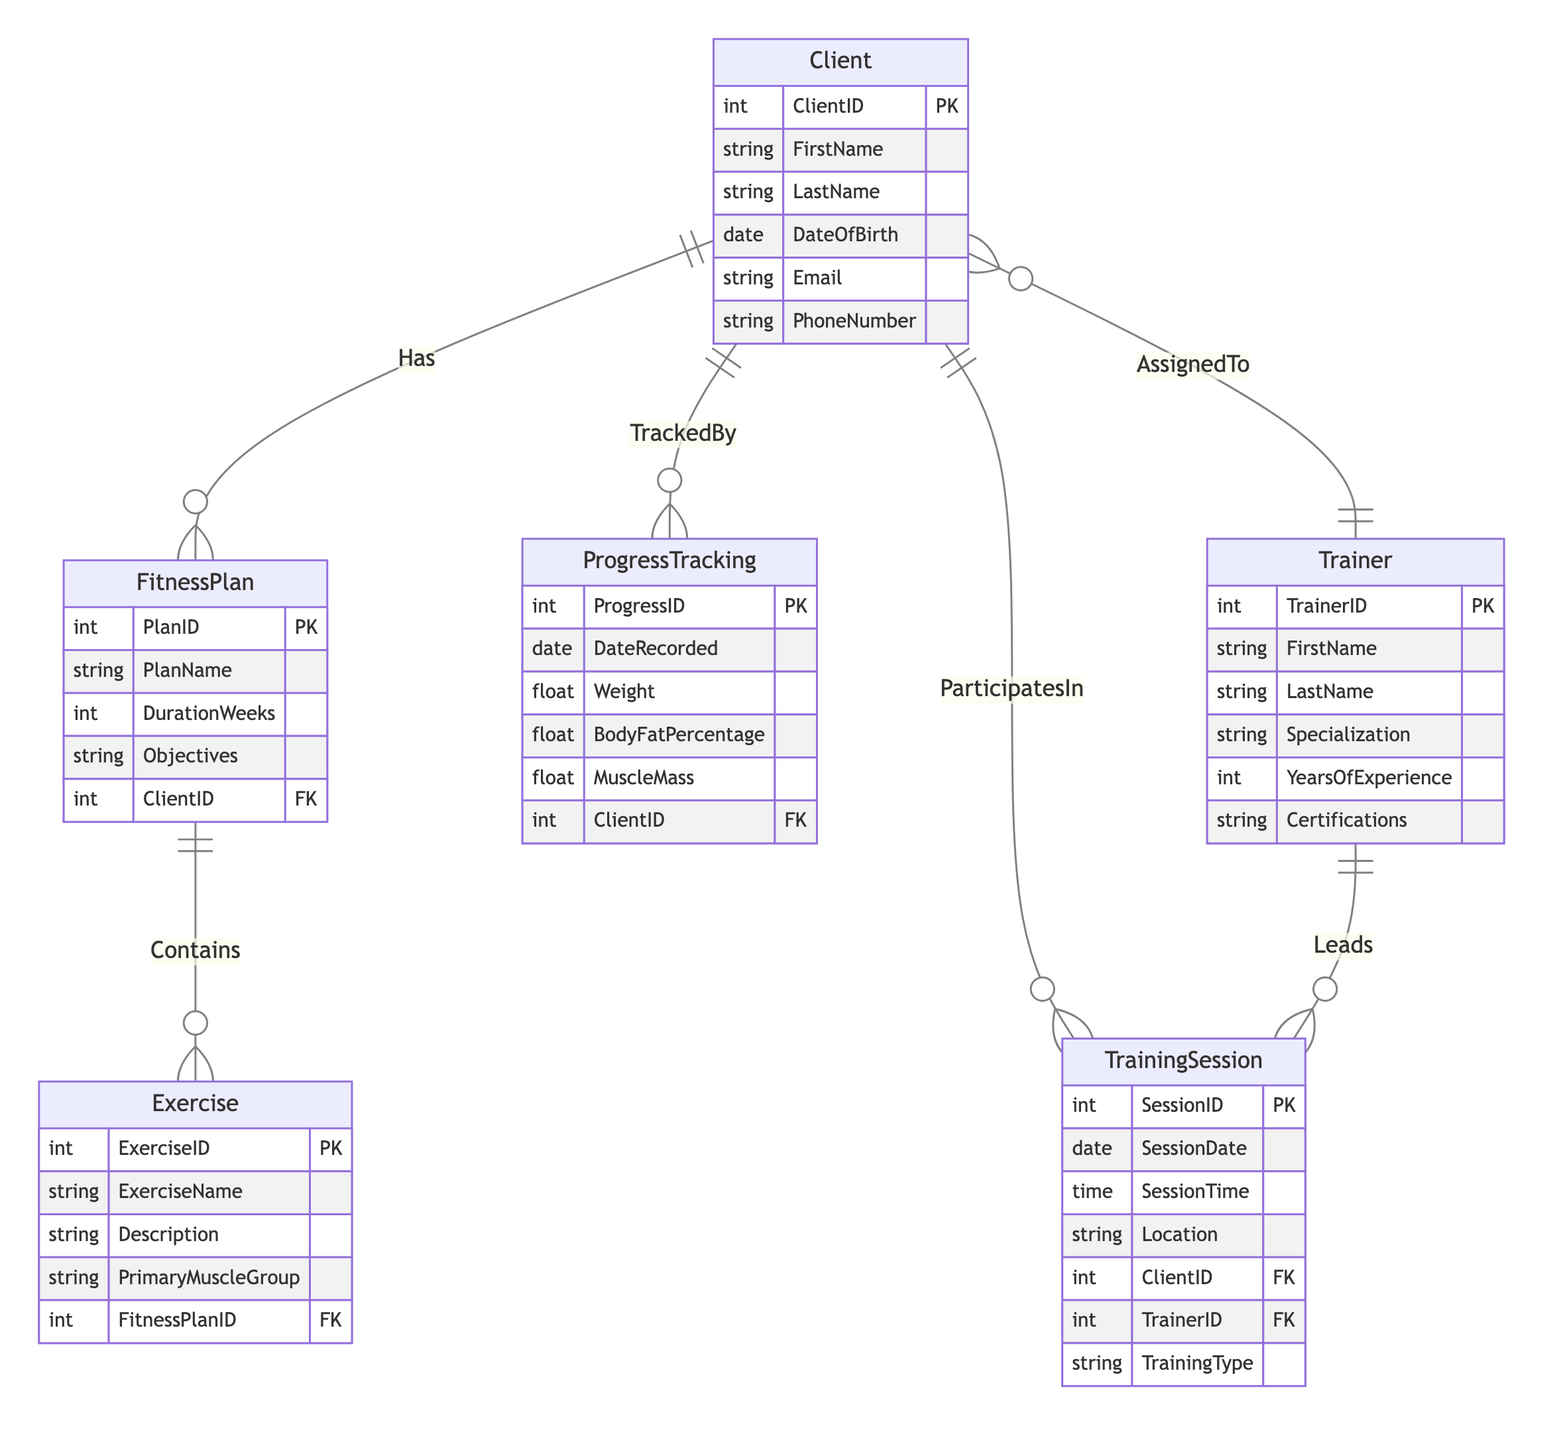What is the primary key of the Client entity? The primary key of the Client entity is defined as ClientID. It is specified under the attributes of the Client entity in the diagram.
Answer: ClientID How many attributes does the Trainer entity have? The Trainer entity has six attributes listed: TrainerID, FirstName, LastName, Specialization, YearsOfExperience, and Certifications. Counting these gives us a total of six attributes.
Answer: 6 What relationship exists between Client and Trainer? The relationship defined between Client and Trainer is "AssignedTo", indicating that each Client is assigned to one Trainer, which reflects a Many-to-One relationship.
Answer: AssignedTo How many different entities are there in the diagram? The diagram lists six entities, which are Client, Trainer, TrainingSession, FitnessPlan, Exercise, and ProgressTracking. Counting these gives us six distinct entities.
Answer: 6 What does a FitnessPlan contain? A FitnessPlan contains Exercises, which is defined by the relationship "Contains". This means that there can be multiple Exercises associated with a single FitnessPlan.
Answer: Exercises Which entity tracks the progress of clients? The ProgressTracking entity is responsible for tracking the progress of clients, as indicated by its direct relationship with the Client entity labeled "TrackedBy".
Answer: ProgressTracking How many training sessions can a Client participate in? The relationship between Client and TrainingSession is One-to-Many, meaning a Client can participate in multiple TrainingSessions. Thus, there is no specific limit stated in the diagram.
Answer: Multiple What is the foreign key in the ProgressTracking entity? The foreign key in the ProgressTracking entity is ClientID, which links it back to the Client entity, allowing the tracking of progress for each individual Client.
Answer: ClientID Which entity has the most comprehensive data? The Trainer entity may be considered the one with comprehensive data due to its various attributes concerning professionalism, including Specialization, YearsOfExperience, and Certifications.
Answer: Trainer 